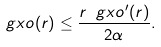<formula> <loc_0><loc_0><loc_500><loc_500>\ g x o ( r ) \leq \frac { r \ g x o ^ { \prime } ( r ) } { 2 \alpha } .</formula> 